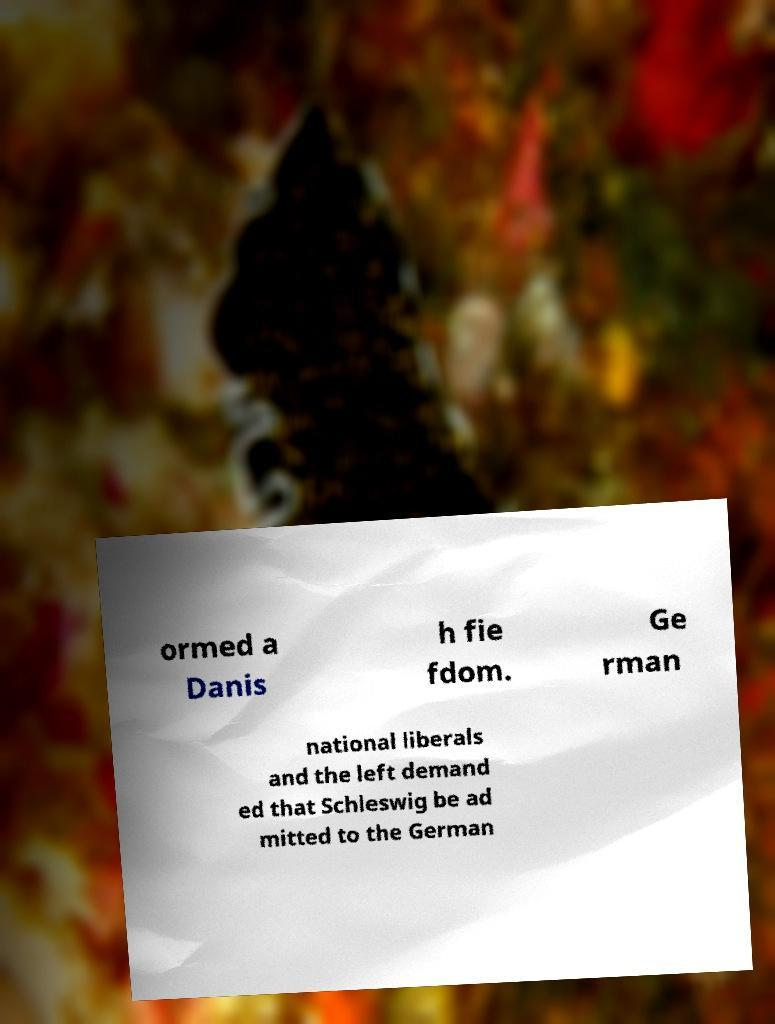What messages or text are displayed in this image? I need them in a readable, typed format. ormed a Danis h fie fdom. Ge rman national liberals and the left demand ed that Schleswig be ad mitted to the German 